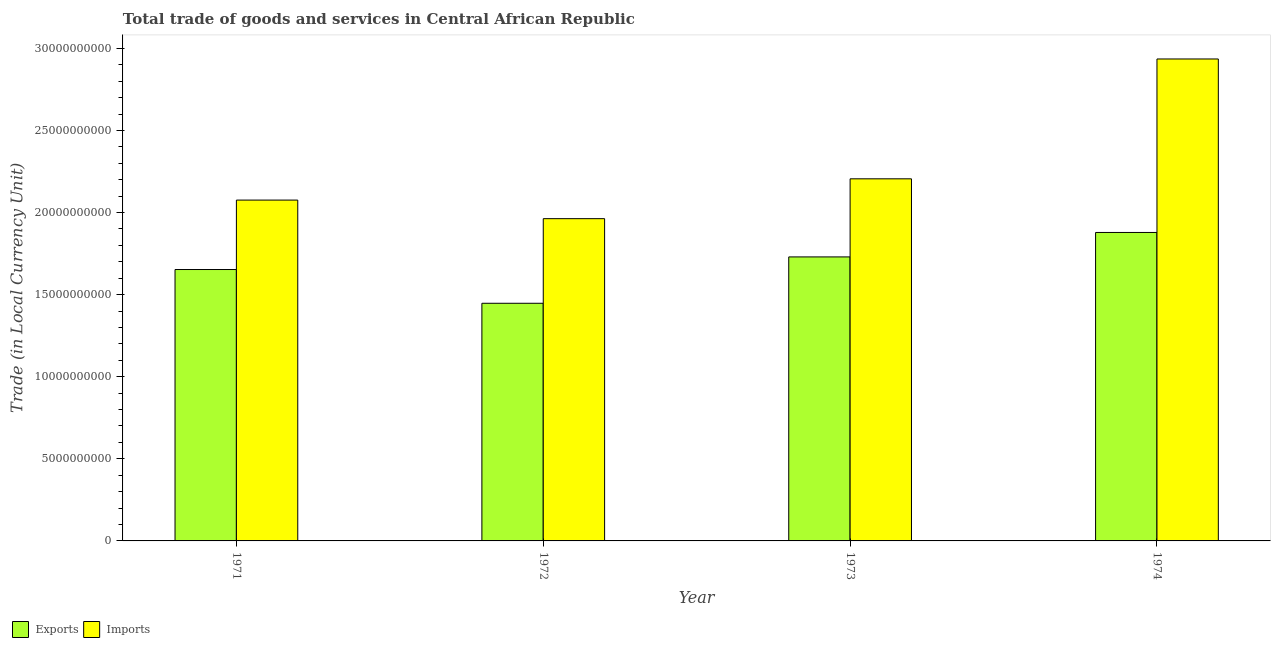Are the number of bars on each tick of the X-axis equal?
Your answer should be very brief. Yes. What is the label of the 4th group of bars from the left?
Offer a terse response. 1974. What is the export of goods and services in 1972?
Provide a succinct answer. 1.45e+1. Across all years, what is the maximum export of goods and services?
Make the answer very short. 1.88e+1. Across all years, what is the minimum imports of goods and services?
Provide a short and direct response. 1.96e+1. In which year was the export of goods and services maximum?
Your answer should be very brief. 1974. In which year was the export of goods and services minimum?
Keep it short and to the point. 1972. What is the total imports of goods and services in the graph?
Keep it short and to the point. 9.18e+1. What is the difference between the imports of goods and services in 1971 and that in 1974?
Provide a short and direct response. -8.59e+09. What is the difference between the imports of goods and services in 1974 and the export of goods and services in 1972?
Keep it short and to the point. 9.73e+09. What is the average export of goods and services per year?
Keep it short and to the point. 1.68e+1. In the year 1974, what is the difference between the imports of goods and services and export of goods and services?
Your answer should be very brief. 0. What is the ratio of the imports of goods and services in 1973 to that in 1974?
Give a very brief answer. 0.75. Is the difference between the imports of goods and services in 1973 and 1974 greater than the difference between the export of goods and services in 1973 and 1974?
Provide a short and direct response. No. What is the difference between the highest and the second highest imports of goods and services?
Ensure brevity in your answer.  7.30e+09. What is the difference between the highest and the lowest export of goods and services?
Your response must be concise. 4.31e+09. What does the 1st bar from the left in 1972 represents?
Give a very brief answer. Exports. What does the 1st bar from the right in 1971 represents?
Your answer should be compact. Imports. How many bars are there?
Ensure brevity in your answer.  8. Are all the bars in the graph horizontal?
Make the answer very short. No. What is the difference between two consecutive major ticks on the Y-axis?
Keep it short and to the point. 5.00e+09. Are the values on the major ticks of Y-axis written in scientific E-notation?
Your answer should be compact. No. Does the graph contain any zero values?
Give a very brief answer. No. How are the legend labels stacked?
Ensure brevity in your answer.  Horizontal. What is the title of the graph?
Your response must be concise. Total trade of goods and services in Central African Republic. What is the label or title of the Y-axis?
Ensure brevity in your answer.  Trade (in Local Currency Unit). What is the Trade (in Local Currency Unit) in Exports in 1971?
Give a very brief answer. 1.65e+1. What is the Trade (in Local Currency Unit) in Imports in 1971?
Your response must be concise. 2.08e+1. What is the Trade (in Local Currency Unit) of Exports in 1972?
Make the answer very short. 1.45e+1. What is the Trade (in Local Currency Unit) of Imports in 1972?
Your response must be concise. 1.96e+1. What is the Trade (in Local Currency Unit) of Exports in 1973?
Offer a very short reply. 1.73e+1. What is the Trade (in Local Currency Unit) in Imports in 1973?
Provide a succinct answer. 2.21e+1. What is the Trade (in Local Currency Unit) of Exports in 1974?
Give a very brief answer. 1.88e+1. What is the Trade (in Local Currency Unit) in Imports in 1974?
Offer a very short reply. 2.94e+1. Across all years, what is the maximum Trade (in Local Currency Unit) of Exports?
Keep it short and to the point. 1.88e+1. Across all years, what is the maximum Trade (in Local Currency Unit) of Imports?
Provide a succinct answer. 2.94e+1. Across all years, what is the minimum Trade (in Local Currency Unit) of Exports?
Provide a succinct answer. 1.45e+1. Across all years, what is the minimum Trade (in Local Currency Unit) in Imports?
Make the answer very short. 1.96e+1. What is the total Trade (in Local Currency Unit) in Exports in the graph?
Your answer should be very brief. 6.71e+1. What is the total Trade (in Local Currency Unit) of Imports in the graph?
Provide a short and direct response. 9.18e+1. What is the difference between the Trade (in Local Currency Unit) of Exports in 1971 and that in 1972?
Provide a short and direct response. 2.06e+09. What is the difference between the Trade (in Local Currency Unit) in Imports in 1971 and that in 1972?
Your answer should be compact. 1.13e+09. What is the difference between the Trade (in Local Currency Unit) in Exports in 1971 and that in 1973?
Give a very brief answer. -7.68e+08. What is the difference between the Trade (in Local Currency Unit) of Imports in 1971 and that in 1973?
Your answer should be very brief. -1.29e+09. What is the difference between the Trade (in Local Currency Unit) of Exports in 1971 and that in 1974?
Your answer should be very brief. -2.26e+09. What is the difference between the Trade (in Local Currency Unit) in Imports in 1971 and that in 1974?
Make the answer very short. -8.59e+09. What is the difference between the Trade (in Local Currency Unit) of Exports in 1972 and that in 1973?
Your response must be concise. -2.82e+09. What is the difference between the Trade (in Local Currency Unit) of Imports in 1972 and that in 1973?
Your answer should be very brief. -2.43e+09. What is the difference between the Trade (in Local Currency Unit) of Exports in 1972 and that in 1974?
Offer a very short reply. -4.31e+09. What is the difference between the Trade (in Local Currency Unit) of Imports in 1972 and that in 1974?
Offer a very short reply. -9.73e+09. What is the difference between the Trade (in Local Currency Unit) in Exports in 1973 and that in 1974?
Make the answer very short. -1.49e+09. What is the difference between the Trade (in Local Currency Unit) in Imports in 1973 and that in 1974?
Make the answer very short. -7.30e+09. What is the difference between the Trade (in Local Currency Unit) of Exports in 1971 and the Trade (in Local Currency Unit) of Imports in 1972?
Your answer should be compact. -3.10e+09. What is the difference between the Trade (in Local Currency Unit) in Exports in 1971 and the Trade (in Local Currency Unit) in Imports in 1973?
Keep it short and to the point. -5.52e+09. What is the difference between the Trade (in Local Currency Unit) in Exports in 1971 and the Trade (in Local Currency Unit) in Imports in 1974?
Provide a succinct answer. -1.28e+1. What is the difference between the Trade (in Local Currency Unit) in Exports in 1972 and the Trade (in Local Currency Unit) in Imports in 1973?
Provide a short and direct response. -7.58e+09. What is the difference between the Trade (in Local Currency Unit) of Exports in 1972 and the Trade (in Local Currency Unit) of Imports in 1974?
Your answer should be compact. -1.49e+1. What is the difference between the Trade (in Local Currency Unit) of Exports in 1973 and the Trade (in Local Currency Unit) of Imports in 1974?
Give a very brief answer. -1.21e+1. What is the average Trade (in Local Currency Unit) in Exports per year?
Your answer should be compact. 1.68e+1. What is the average Trade (in Local Currency Unit) of Imports per year?
Make the answer very short. 2.29e+1. In the year 1971, what is the difference between the Trade (in Local Currency Unit) of Exports and Trade (in Local Currency Unit) of Imports?
Make the answer very short. -4.23e+09. In the year 1972, what is the difference between the Trade (in Local Currency Unit) in Exports and Trade (in Local Currency Unit) in Imports?
Offer a terse response. -5.15e+09. In the year 1973, what is the difference between the Trade (in Local Currency Unit) of Exports and Trade (in Local Currency Unit) of Imports?
Provide a short and direct response. -4.76e+09. In the year 1974, what is the difference between the Trade (in Local Currency Unit) of Exports and Trade (in Local Currency Unit) of Imports?
Your answer should be very brief. -1.06e+1. What is the ratio of the Trade (in Local Currency Unit) in Exports in 1971 to that in 1972?
Your answer should be very brief. 1.14. What is the ratio of the Trade (in Local Currency Unit) in Imports in 1971 to that in 1972?
Keep it short and to the point. 1.06. What is the ratio of the Trade (in Local Currency Unit) in Exports in 1971 to that in 1973?
Your answer should be compact. 0.96. What is the ratio of the Trade (in Local Currency Unit) of Imports in 1971 to that in 1973?
Provide a short and direct response. 0.94. What is the ratio of the Trade (in Local Currency Unit) of Exports in 1971 to that in 1974?
Offer a terse response. 0.88. What is the ratio of the Trade (in Local Currency Unit) in Imports in 1971 to that in 1974?
Make the answer very short. 0.71. What is the ratio of the Trade (in Local Currency Unit) in Exports in 1972 to that in 1973?
Provide a short and direct response. 0.84. What is the ratio of the Trade (in Local Currency Unit) in Imports in 1972 to that in 1973?
Your answer should be compact. 0.89. What is the ratio of the Trade (in Local Currency Unit) in Exports in 1972 to that in 1974?
Your answer should be very brief. 0.77. What is the ratio of the Trade (in Local Currency Unit) of Imports in 1972 to that in 1974?
Your response must be concise. 0.67. What is the ratio of the Trade (in Local Currency Unit) of Exports in 1973 to that in 1974?
Make the answer very short. 0.92. What is the ratio of the Trade (in Local Currency Unit) in Imports in 1973 to that in 1974?
Your answer should be compact. 0.75. What is the difference between the highest and the second highest Trade (in Local Currency Unit) in Exports?
Offer a terse response. 1.49e+09. What is the difference between the highest and the second highest Trade (in Local Currency Unit) in Imports?
Keep it short and to the point. 7.30e+09. What is the difference between the highest and the lowest Trade (in Local Currency Unit) in Exports?
Offer a terse response. 4.31e+09. What is the difference between the highest and the lowest Trade (in Local Currency Unit) of Imports?
Ensure brevity in your answer.  9.73e+09. 